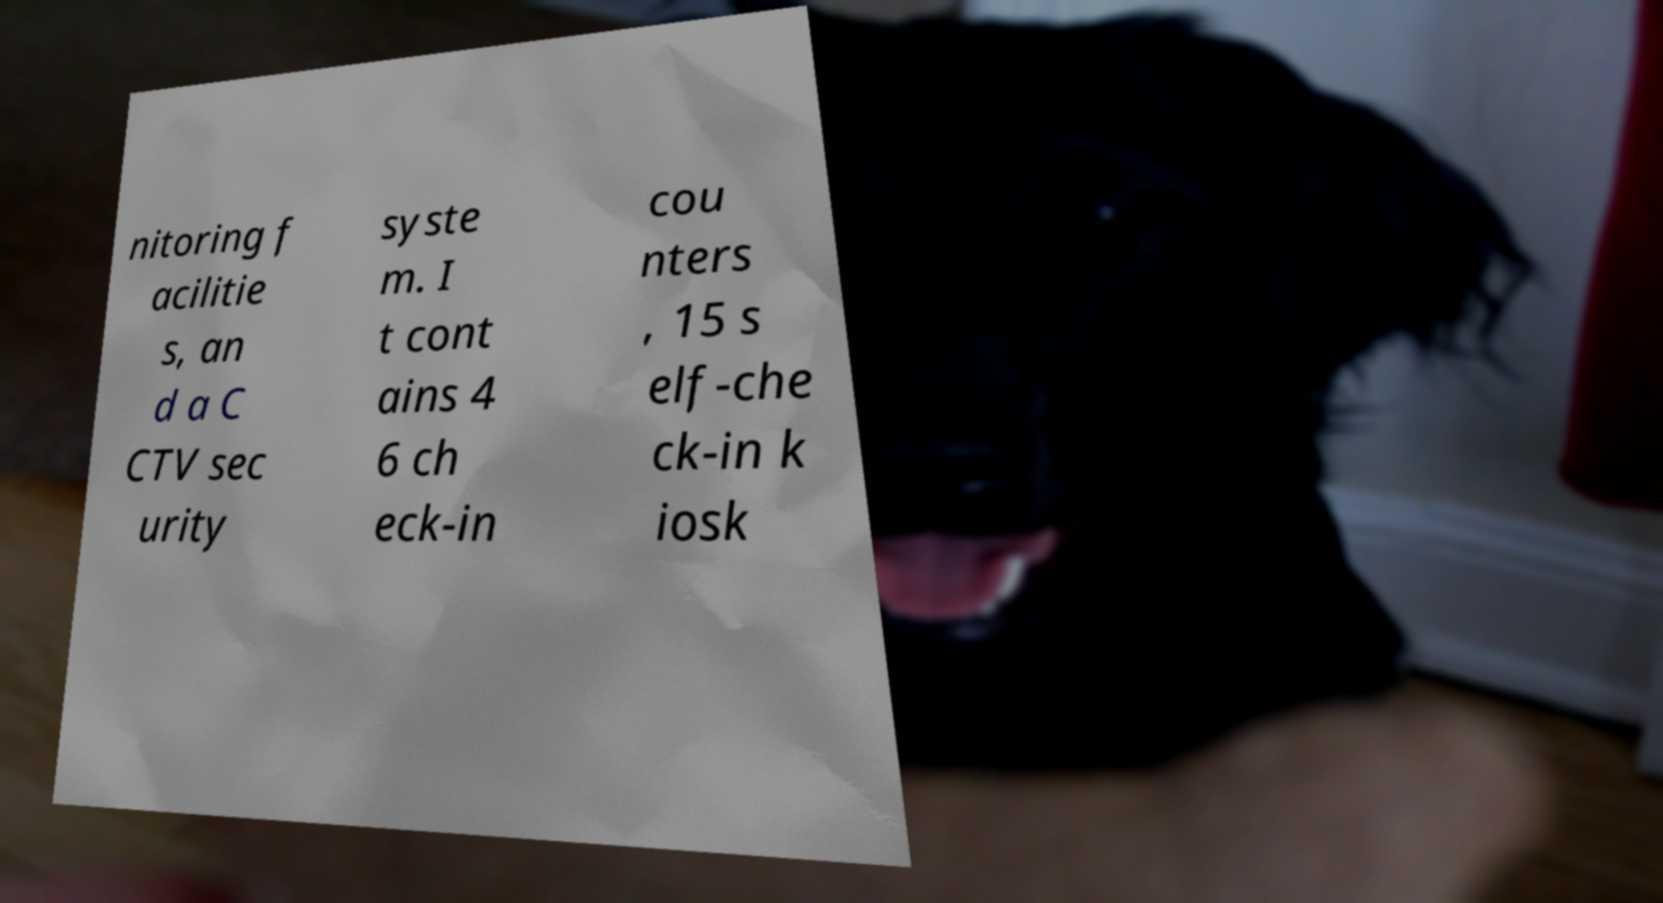Please identify and transcribe the text found in this image. nitoring f acilitie s, an d a C CTV sec urity syste m. I t cont ains 4 6 ch eck-in cou nters , 15 s elf-che ck-in k iosk 